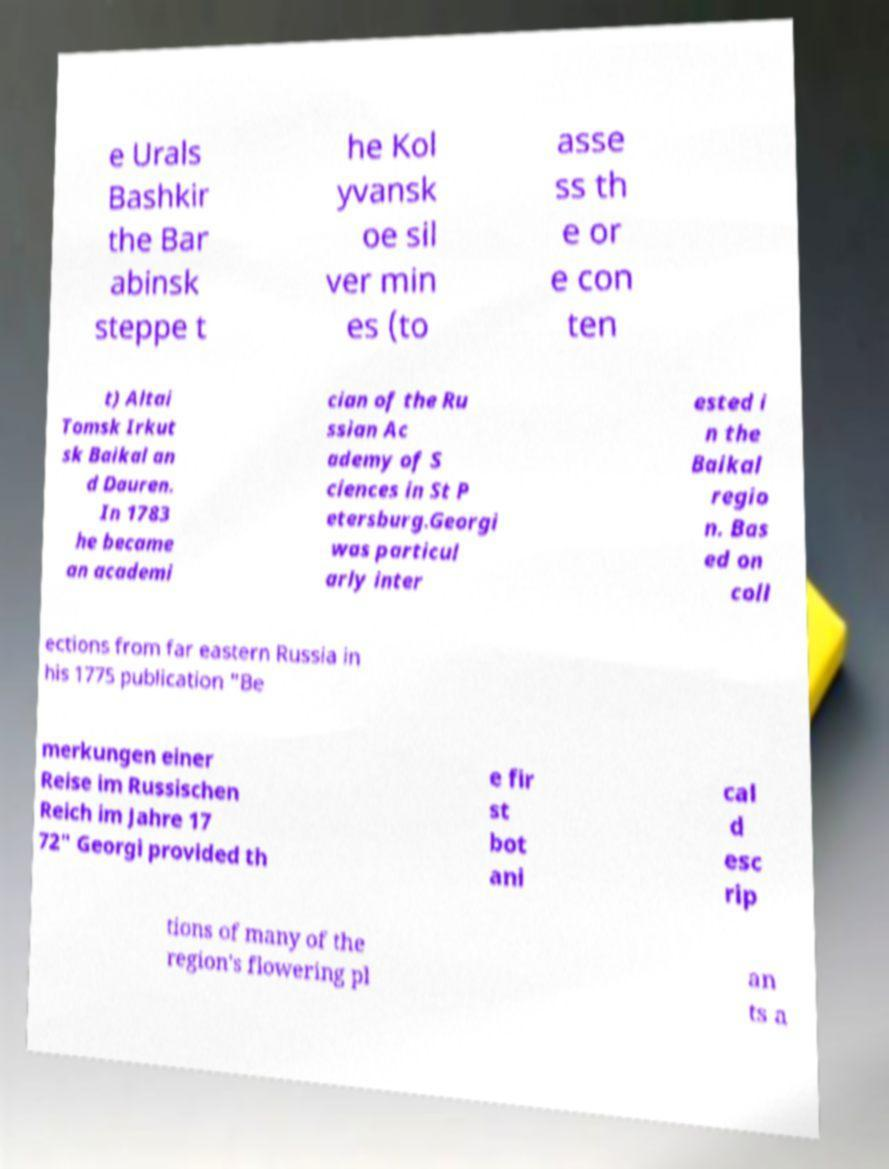There's text embedded in this image that I need extracted. Can you transcribe it verbatim? e Urals Bashkir the Bar abinsk steppe t he Kol yvansk oe sil ver min es (to asse ss th e or e con ten t) Altai Tomsk Irkut sk Baikal an d Dauren. In 1783 he became an academi cian of the Ru ssian Ac ademy of S ciences in St P etersburg.Georgi was particul arly inter ested i n the Baikal regio n. Bas ed on coll ections from far eastern Russia in his 1775 publication "Be merkungen einer Reise im Russischen Reich im Jahre 17 72" Georgi provided th e fir st bot ani cal d esc rip tions of many of the region's flowering pl an ts a 